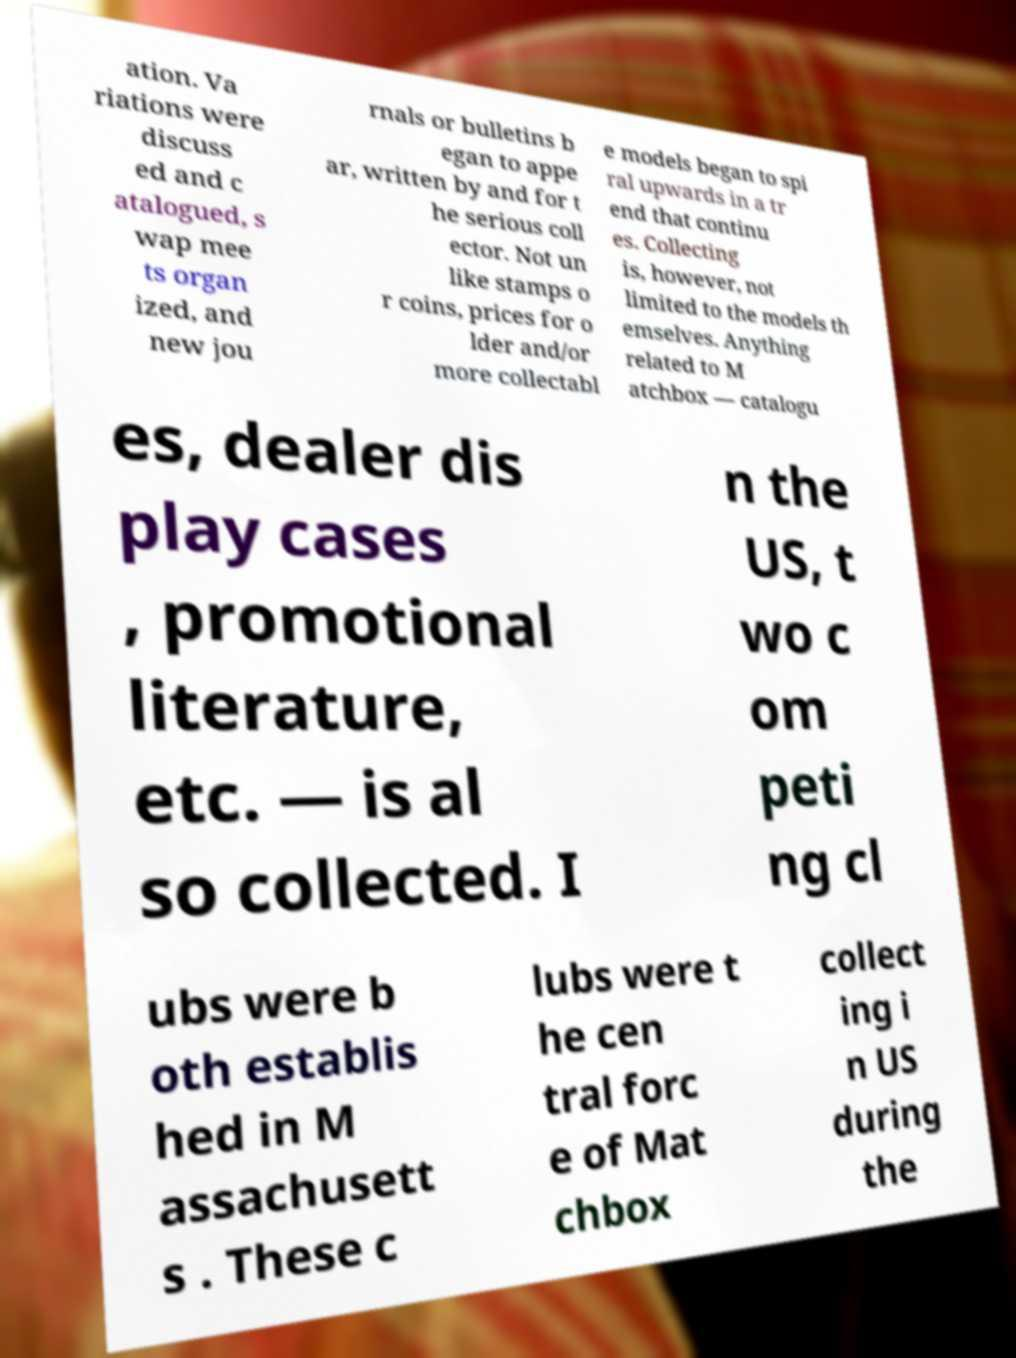What messages or text are displayed in this image? I need them in a readable, typed format. ation. Va riations were discuss ed and c atalogued, s wap mee ts organ ized, and new jou rnals or bulletins b egan to appe ar, written by and for t he serious coll ector. Not un like stamps o r coins, prices for o lder and/or more collectabl e models began to spi ral upwards in a tr end that continu es. Collecting is, however, not limited to the models th emselves. Anything related to M atchbox ― catalogu es, dealer dis play cases , promotional literature, etc. ― is al so collected. I n the US, t wo c om peti ng cl ubs were b oth establis hed in M assachusett s . These c lubs were t he cen tral forc e of Mat chbox collect ing i n US during the 